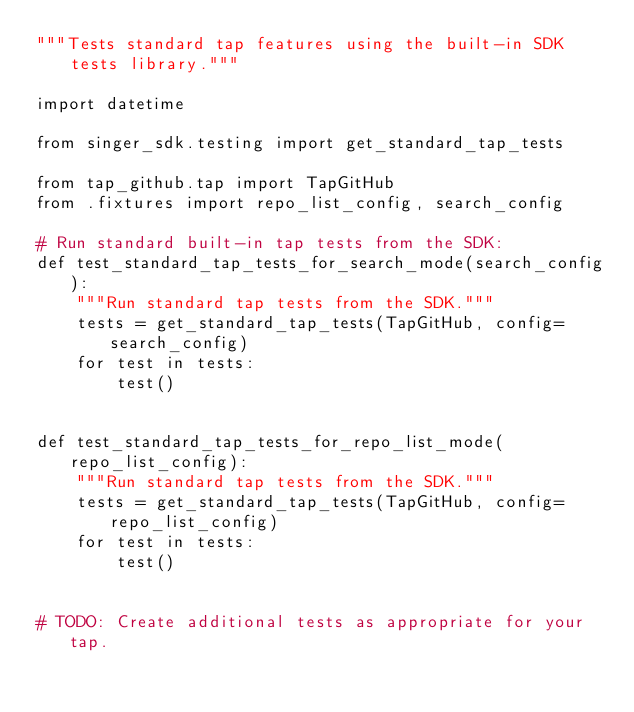Convert code to text. <code><loc_0><loc_0><loc_500><loc_500><_Python_>"""Tests standard tap features using the built-in SDK tests library."""

import datetime

from singer_sdk.testing import get_standard_tap_tests

from tap_github.tap import TapGitHub
from .fixtures import repo_list_config, search_config

# Run standard built-in tap tests from the SDK:
def test_standard_tap_tests_for_search_mode(search_config):
    """Run standard tap tests from the SDK."""
    tests = get_standard_tap_tests(TapGitHub, config=search_config)
    for test in tests:
        test()


def test_standard_tap_tests_for_repo_list_mode(repo_list_config):
    """Run standard tap tests from the SDK."""
    tests = get_standard_tap_tests(TapGitHub, config=repo_list_config)
    for test in tests:
        test()


# TODO: Create additional tests as appropriate for your tap.
</code> 